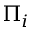<formula> <loc_0><loc_0><loc_500><loc_500>\Pi _ { i }</formula> 